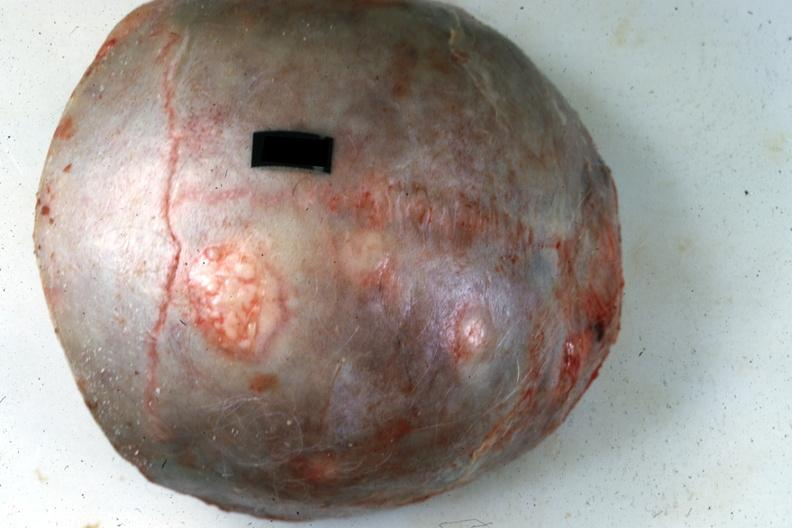does this image show top of calvaria typical lesions source?
Answer the question using a single word or phrase. Yes 